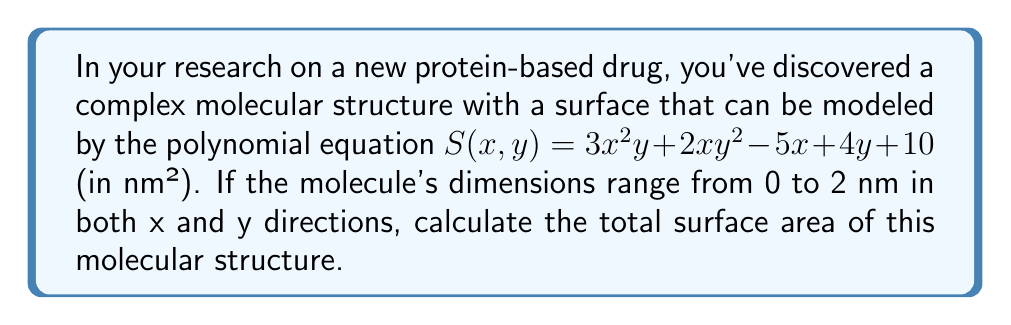Show me your answer to this math problem. To calculate the total surface area, we need to integrate the surface function $S(x,y)$ over the given domain. We'll use a double integral for this:

1) Set up the double integral:
   $$\iint_D S(x,y) \,dA = \int_0^2 \int_0^2 (3x^2y + 2xy^2 - 5x + 4y + 10) \,dx\,dy$$

2) Integrate with respect to x first:
   $$\int_0^2 (x^3y + x^2y^2 - \frac{5}{2}x^2 + 4xy + 10x)\bigg|_0^2 \,dy$$

3) Evaluate the inner integral:
   $$\int_0^2 (8y + 4y^2 - 10 + 8y + 20) \,dy$$

4) Simplify:
   $$\int_0^2 (4y^2 + 16y + 10) \,dy$$

5) Integrate with respect to y:
   $$\left[\frac{4}{3}y^3 + 8y^2 + 10y\right]_0^2$$

6) Evaluate the outer integral:
   $$\frac{32}{3} + 32 + 20 = \frac{32}{3} + 52 = \frac{208}{3}$$

Therefore, the total surface area is $\frac{208}{3}$ nm².
Answer: $\frac{208}{3}$ nm² 